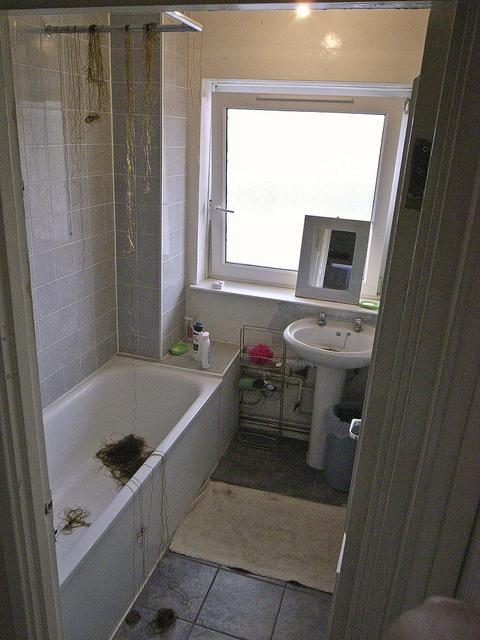Is there a bathtub in this picture?
Keep it brief. Yes. Is the bathtub clean?
Short answer required. No. What is on the shelf behind the bathtub?
Answer briefly. Mirror. Is this place clean?
Keep it brief. No. Is the bathroom dirty?
Concise answer only. Yes. Is this image captured at night?
Be succinct. No. 